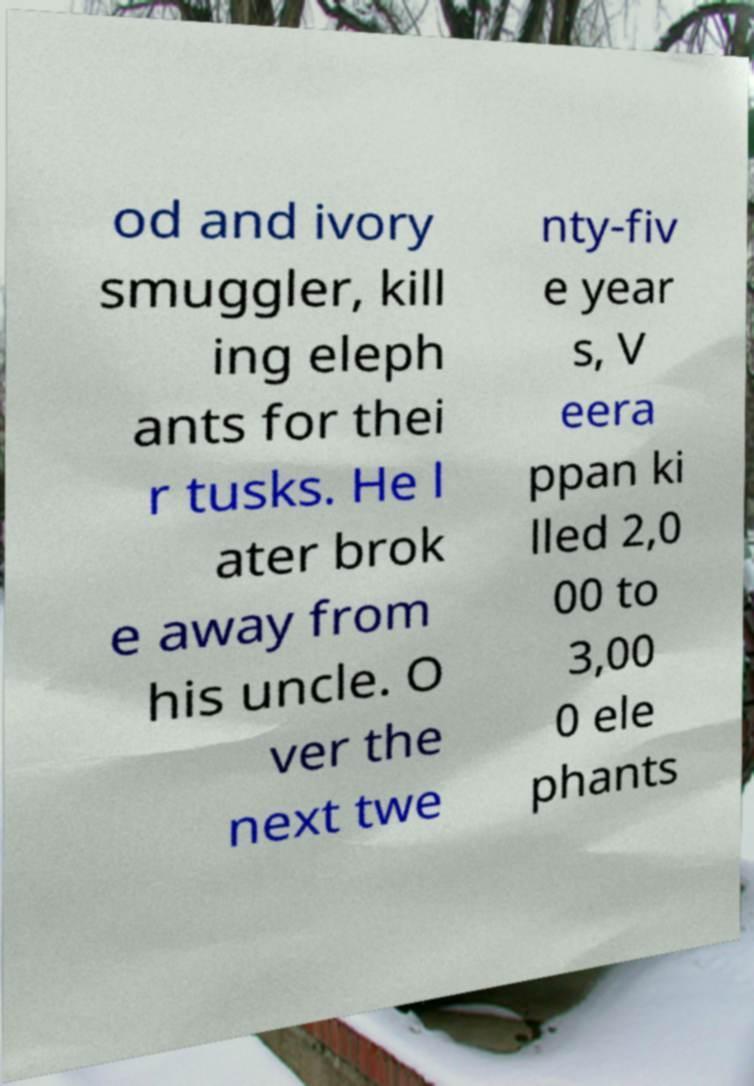Could you extract and type out the text from this image? od and ivory smuggler, kill ing eleph ants for thei r tusks. He l ater brok e away from his uncle. O ver the next twe nty-fiv e year s, V eera ppan ki lled 2,0 00 to 3,00 0 ele phants 